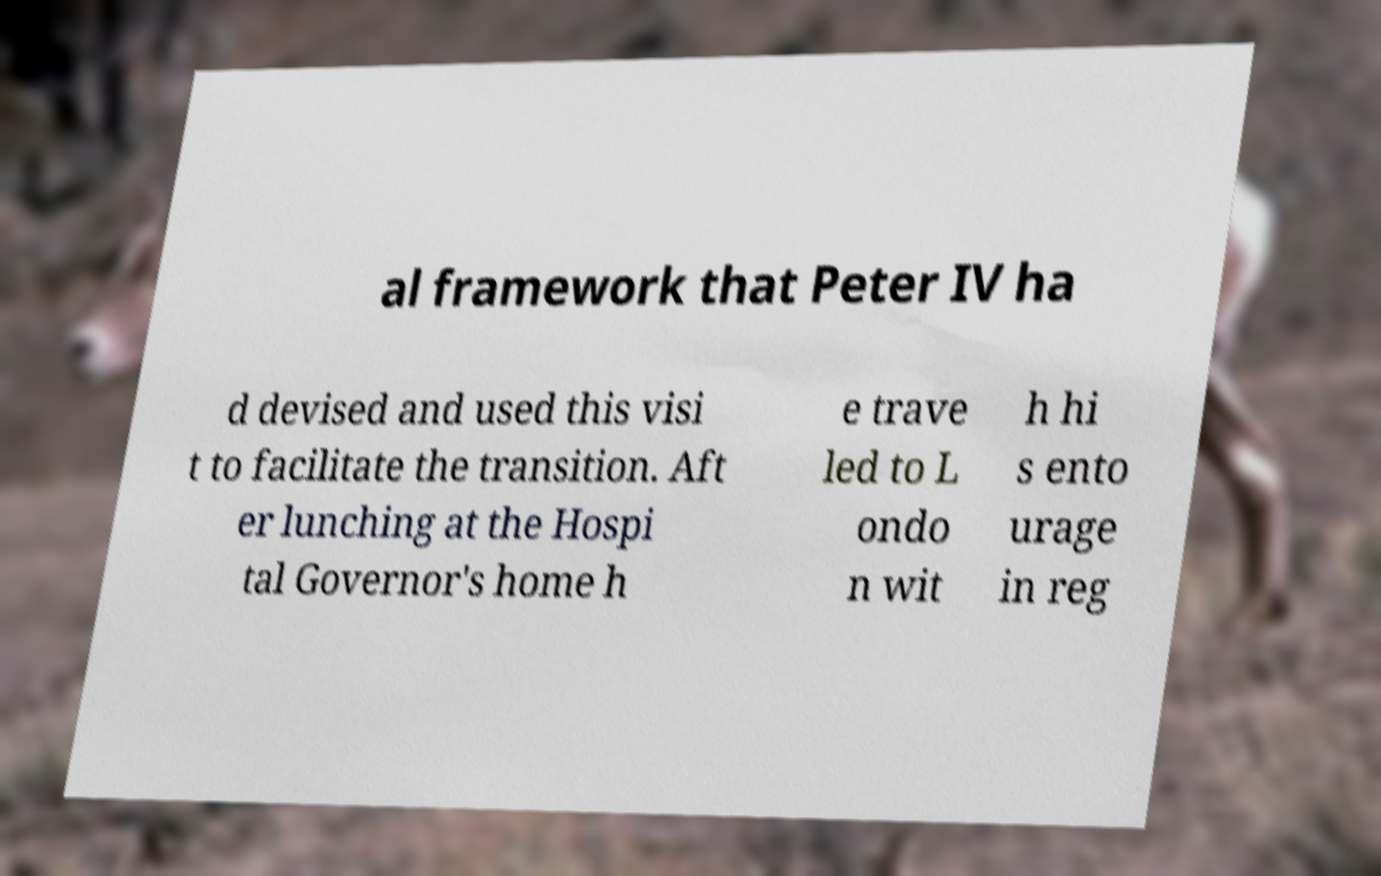Could you extract and type out the text from this image? al framework that Peter IV ha d devised and used this visi t to facilitate the transition. Aft er lunching at the Hospi tal Governor's home h e trave led to L ondo n wit h hi s ento urage in reg 